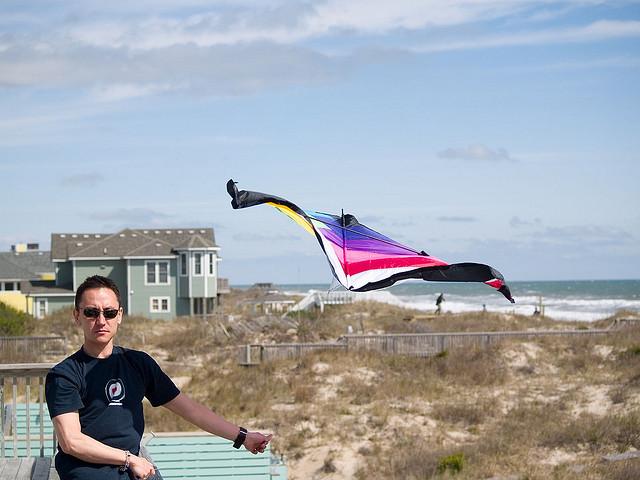Does it look warm enough to wear a swimming suit?
Short answer required. Yes. Is the person in the black shirt a man or a woman?
Write a very short answer. Man. Is there a kite in the sky?
Give a very brief answer. Yes. 